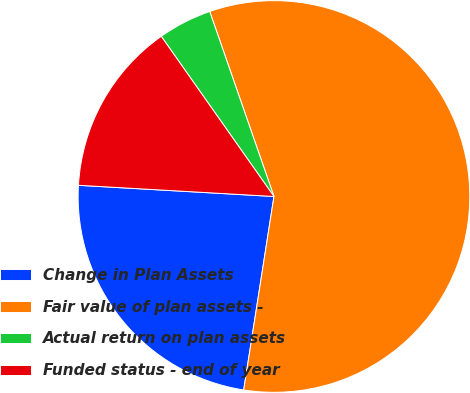<chart> <loc_0><loc_0><loc_500><loc_500><pie_chart><fcel>Change in Plan Assets<fcel>Fair value of plan assets -<fcel>Actual return on plan assets<fcel>Funded status - end of year<nl><fcel>23.44%<fcel>57.79%<fcel>4.44%<fcel>14.33%<nl></chart> 